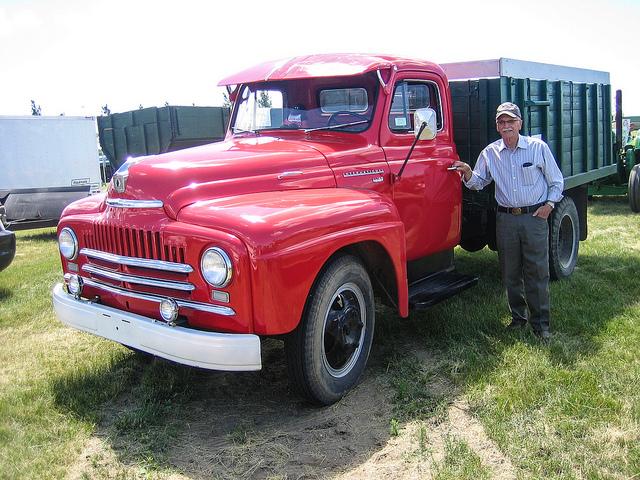Are the truck windows down?
Write a very short answer. Yes. What color is the truck?
Keep it brief. Red. How many people are standing beside the truck?
Keep it brief. 1. Is the front bumper falling off?
Keep it brief. No. Is it a cloudy day?
Be succinct. No. What kind of car is this?
Be succinct. Truck. What is written on the back of the truck?
Short answer required. Nothing. What is this man's job?
Be succinct. Farmer. What is older, the man or the truck?
Quick response, please. Man. What is on the man's face?
Concise answer only. Glasses. What color is the cab?
Keep it brief. Red. 